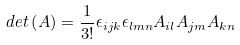Convert formula to latex. <formula><loc_0><loc_0><loc_500><loc_500>d e t \left ( A \right ) = \frac { 1 } { 3 ! } \epsilon _ { i j k } \epsilon _ { l m n } A _ { i l } A _ { j m } A _ { k n }</formula> 